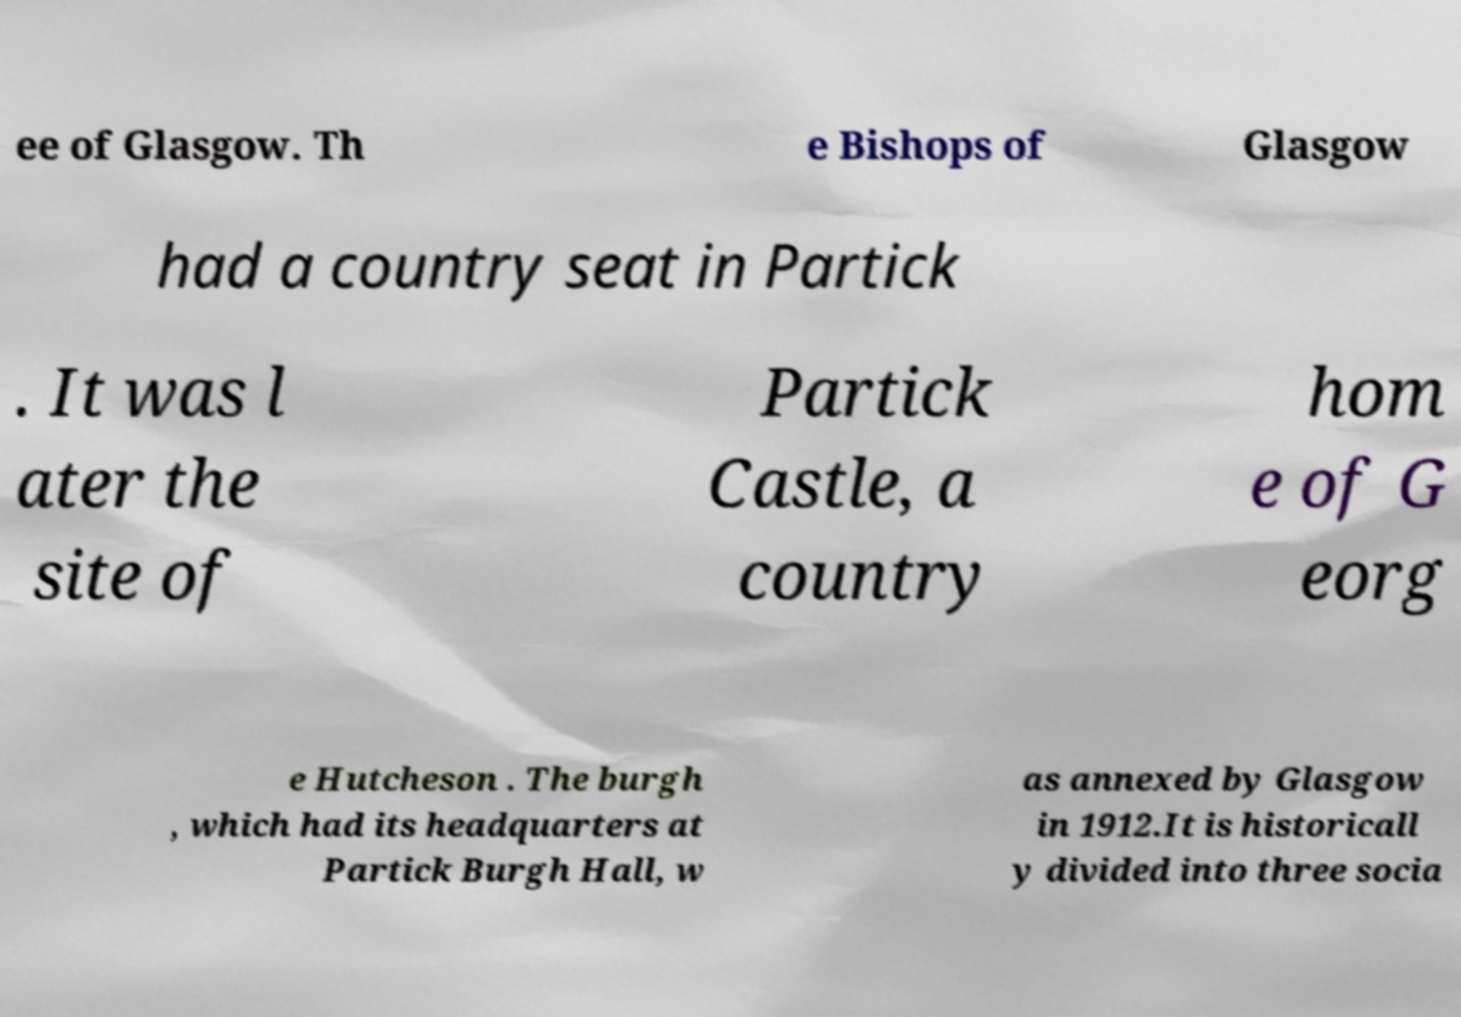Could you assist in decoding the text presented in this image and type it out clearly? ee of Glasgow. Th e Bishops of Glasgow had a country seat in Partick . It was l ater the site of Partick Castle, a country hom e of G eorg e Hutcheson . The burgh , which had its headquarters at Partick Burgh Hall, w as annexed by Glasgow in 1912.It is historicall y divided into three socia 